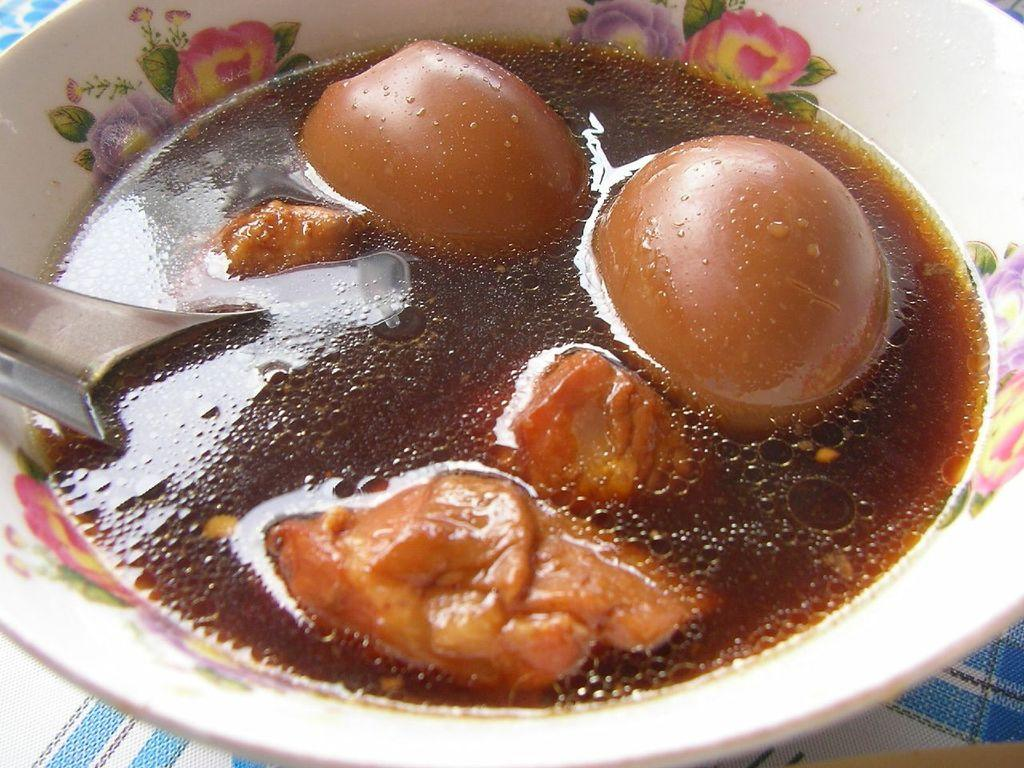What is located in the center of the image? There is a bowl in the middle of the image. What is inside the bowl? The bowl contains food items. What utensil is present in the bowl? A spoon is present in the bowl. What can be seen at the bottom of the image? There is a tablecloth at the bottom of the image. What type of metal can be seen in the tin container in the image? There is no tin container or metal present in the image. 